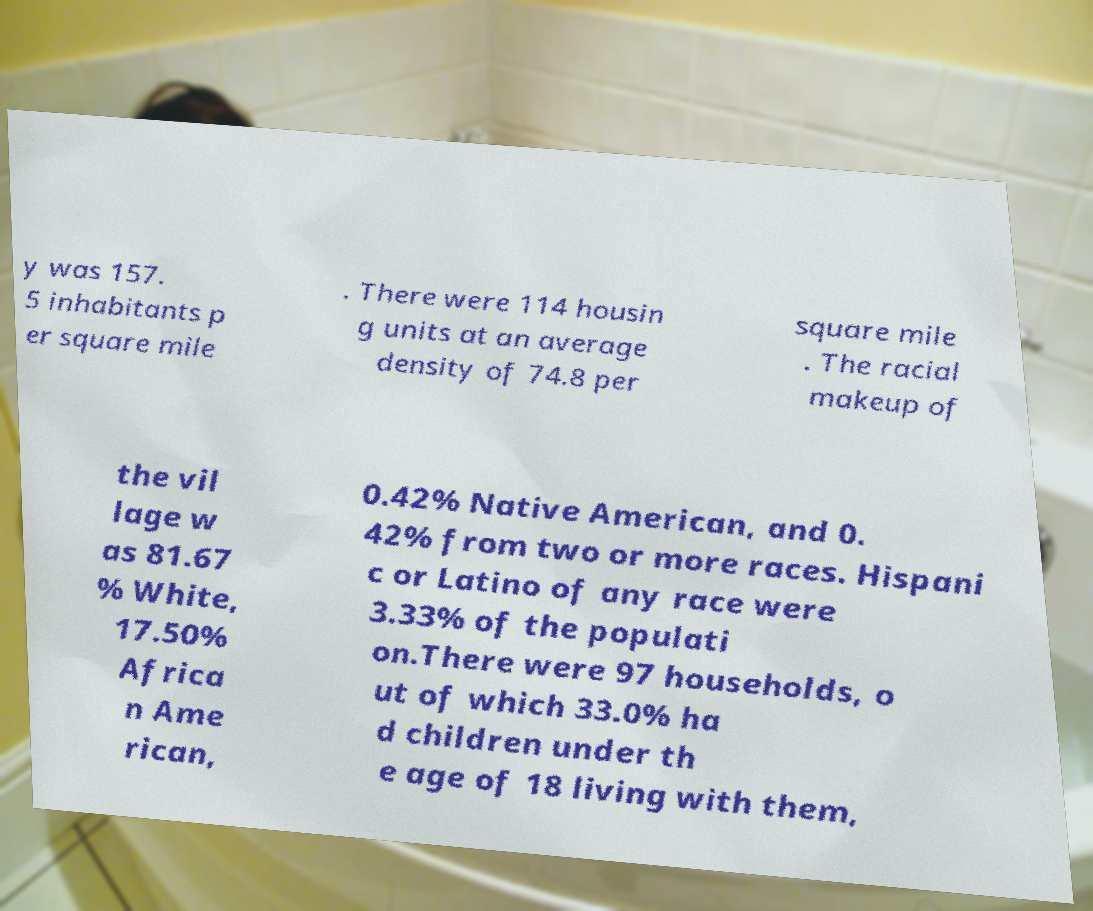Could you assist in decoding the text presented in this image and type it out clearly? y was 157. 5 inhabitants p er square mile . There were 114 housin g units at an average density of 74.8 per square mile . The racial makeup of the vil lage w as 81.67 % White, 17.50% Africa n Ame rican, 0.42% Native American, and 0. 42% from two or more races. Hispani c or Latino of any race were 3.33% of the populati on.There were 97 households, o ut of which 33.0% ha d children under th e age of 18 living with them, 